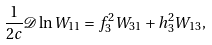<formula> <loc_0><loc_0><loc_500><loc_500>\frac { 1 } { 2 c } \mathcal { D } \ln W _ { 1 1 } = f ^ { 2 } _ { 3 } W _ { 3 1 } + h ^ { 2 } _ { 3 } W _ { 1 3 } ,</formula> 